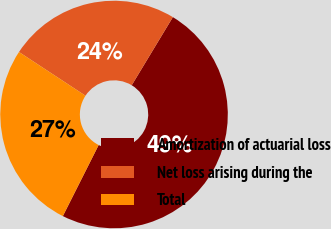Convert chart to OTSL. <chart><loc_0><loc_0><loc_500><loc_500><pie_chart><fcel>Amortization of actuarial loss<fcel>Net loss arising during the<fcel>Total<nl><fcel>48.78%<fcel>24.39%<fcel>26.83%<nl></chart> 